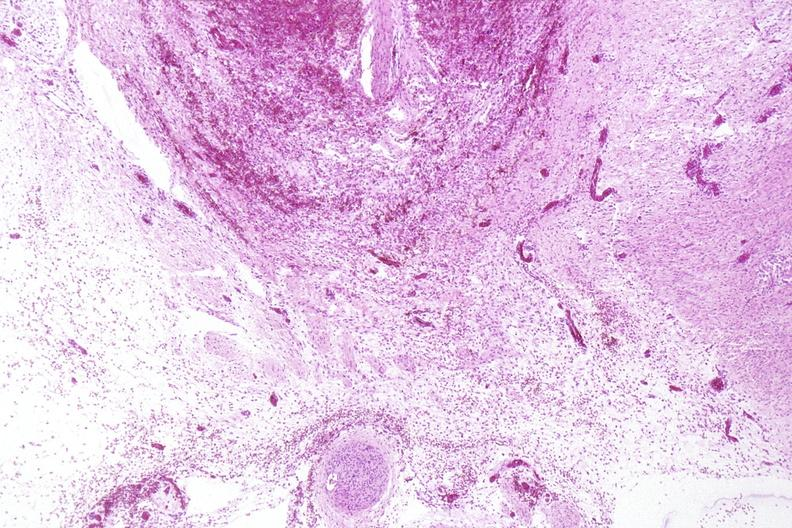does this image show neural tube defect, meningomyelocele?
Answer the question using a single word or phrase. Yes 